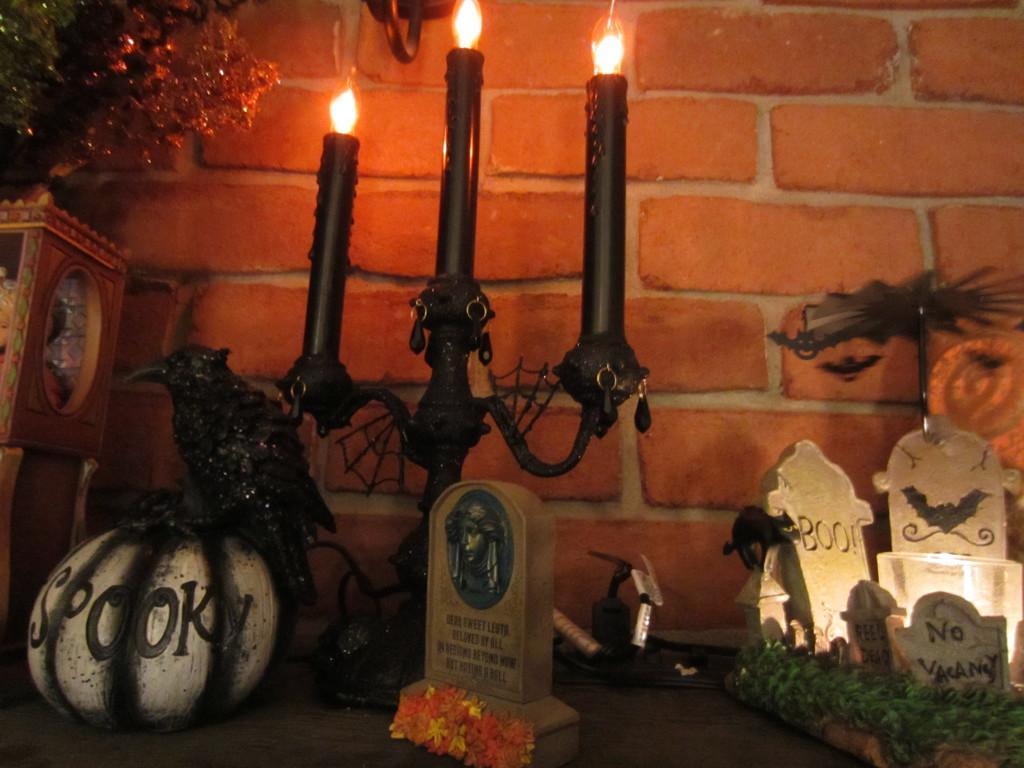Could you give a brief overview of what you see in this image? In this image in the center there are three candles, toys, pumpkin, cemetery, flowers, plants and some boxes. In the background there is a wall. 